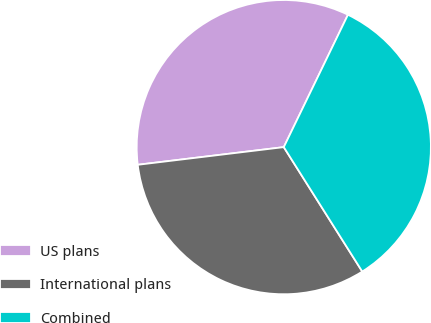<chart> <loc_0><loc_0><loc_500><loc_500><pie_chart><fcel>US plans<fcel>International plans<fcel>Combined<nl><fcel>34.1%<fcel>32.04%<fcel>33.86%<nl></chart> 